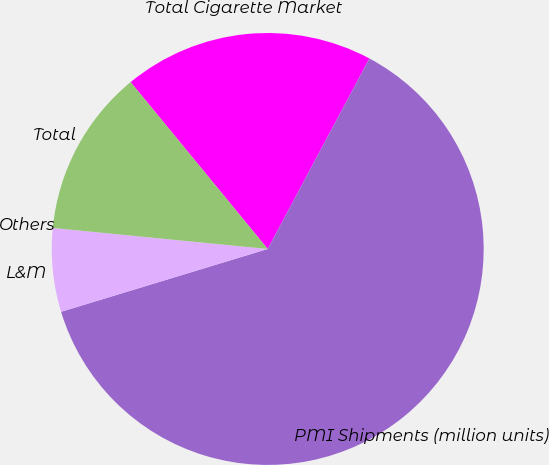Convert chart. <chart><loc_0><loc_0><loc_500><loc_500><pie_chart><fcel>Total Cigarette Market<fcel>PMI Shipments (million units)<fcel>L&M<fcel>Others<fcel>Total<nl><fcel>18.75%<fcel>62.49%<fcel>6.25%<fcel>0.0%<fcel>12.5%<nl></chart> 